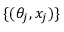Convert formula to latex. <formula><loc_0><loc_0><loc_500><loc_500>\{ ( \theta _ { j } , x _ { j } ) \}</formula> 